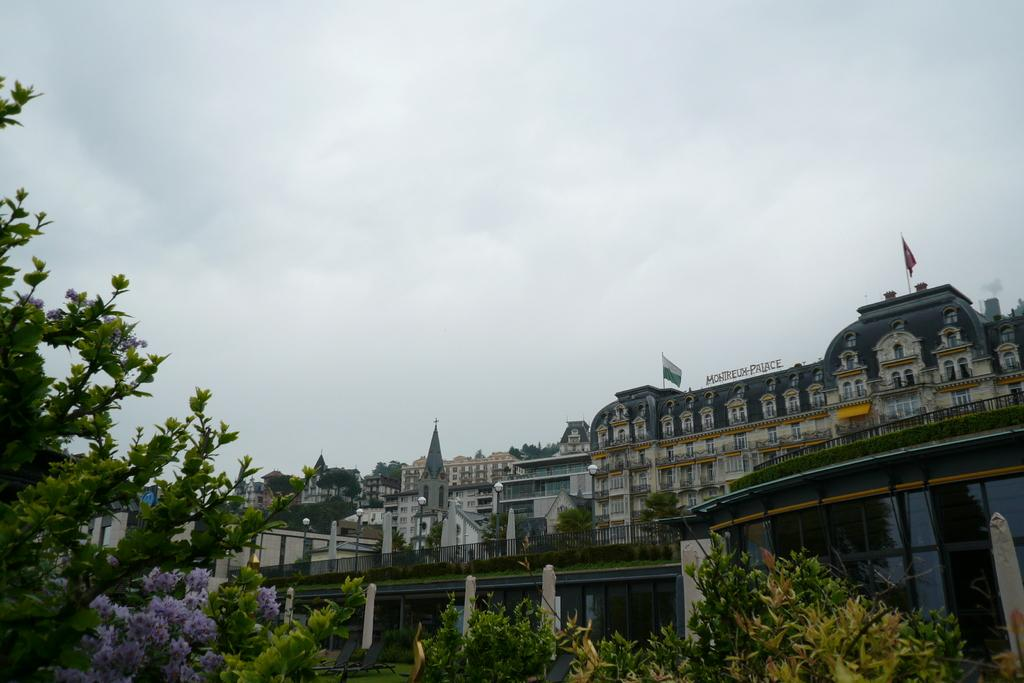What type of natural elements can be seen in the image? There are trees in the image. What type of man-made structures are present in the image? There are buildings in the image. What is attached to the poles near the buildings? There are flags on the poles near the buildings. What is the condition of the sky in the image? The sky is cloudy in the image. What type of chess pieces can be seen on the trees in the image? There are no chess pieces present on the trees in the image. What reason might the cloudy sky be present in the image? The cloudy sky is a natural weather condition and is not present in the image for any specific reason. 